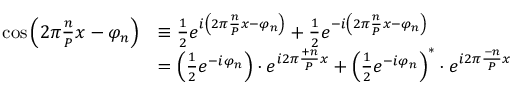<formula> <loc_0><loc_0><loc_500><loc_500>{ \begin{array} { r l } { \cos \left ( 2 \pi { \frac { n } { P } } x - \varphi _ { n } \right ) } & { \equiv \frac { 1 } { 2 } e ^ { i \left ( 2 \pi { \frac { n } { P } } x - \varphi _ { n } \right ) } + { \frac { 1 } { 2 } } e ^ { - i \left ( 2 \pi { \frac { n } { P } } x - \varphi _ { n } \right ) } } \\ & { = \left ( { \frac { 1 } { 2 } } e ^ { - i \varphi _ { n } } \right ) \cdot e ^ { i 2 \pi { \frac { + n } { P } } x } + \left ( { \frac { 1 } { 2 } } e ^ { - i \varphi _ { n } } \right ) ^ { * } \cdot e ^ { i 2 \pi { \frac { - n } { P } } x } } \end{array} }</formula> 